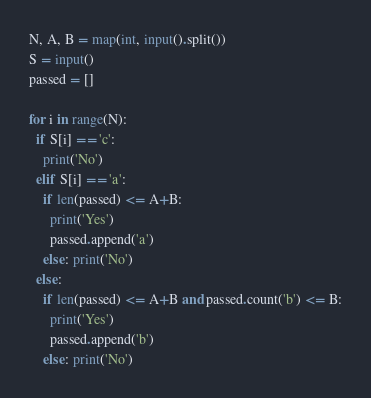Convert code to text. <code><loc_0><loc_0><loc_500><loc_500><_Python_>N, A, B = map(int, input().split())
S = input()
passed = []

for i in range(N):
  if S[i] == 'c':
    print('No')
  elif S[i] == 'a':
    if len(passed) <= A+B:
      print('Yes')
      passed.append('a')
    else: print('No')
  else:
    if len(passed) <= A+B and passed.count('b') <= B:
      print('Yes')
      passed.append('b')
    else: print('No')</code> 